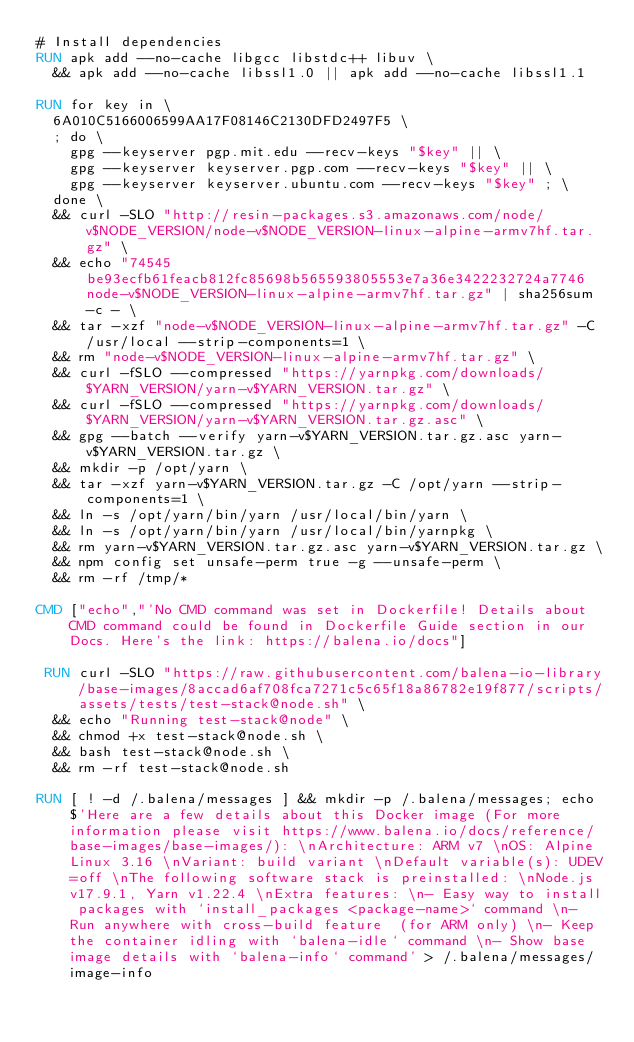<code> <loc_0><loc_0><loc_500><loc_500><_Dockerfile_># Install dependencies
RUN apk add --no-cache libgcc libstdc++ libuv \
	&& apk add --no-cache libssl1.0 || apk add --no-cache libssl1.1

RUN for key in \
	6A010C5166006599AA17F08146C2130DFD2497F5 \
	; do \
		gpg --keyserver pgp.mit.edu --recv-keys "$key" || \
		gpg --keyserver keyserver.pgp.com --recv-keys "$key" || \
		gpg --keyserver keyserver.ubuntu.com --recv-keys "$key" ; \
	done \
	&& curl -SLO "http://resin-packages.s3.amazonaws.com/node/v$NODE_VERSION/node-v$NODE_VERSION-linux-alpine-armv7hf.tar.gz" \
	&& echo "74545be93ecfb61feacb812fc85698b565593805553e7a36e3422232724a7746  node-v$NODE_VERSION-linux-alpine-armv7hf.tar.gz" | sha256sum -c - \
	&& tar -xzf "node-v$NODE_VERSION-linux-alpine-armv7hf.tar.gz" -C /usr/local --strip-components=1 \
	&& rm "node-v$NODE_VERSION-linux-alpine-armv7hf.tar.gz" \
	&& curl -fSLO --compressed "https://yarnpkg.com/downloads/$YARN_VERSION/yarn-v$YARN_VERSION.tar.gz" \
	&& curl -fSLO --compressed "https://yarnpkg.com/downloads/$YARN_VERSION/yarn-v$YARN_VERSION.tar.gz.asc" \
	&& gpg --batch --verify yarn-v$YARN_VERSION.tar.gz.asc yarn-v$YARN_VERSION.tar.gz \
	&& mkdir -p /opt/yarn \
	&& tar -xzf yarn-v$YARN_VERSION.tar.gz -C /opt/yarn --strip-components=1 \
	&& ln -s /opt/yarn/bin/yarn /usr/local/bin/yarn \
	&& ln -s /opt/yarn/bin/yarn /usr/local/bin/yarnpkg \
	&& rm yarn-v$YARN_VERSION.tar.gz.asc yarn-v$YARN_VERSION.tar.gz \
	&& npm config set unsafe-perm true -g --unsafe-perm \
	&& rm -rf /tmp/*

CMD ["echo","'No CMD command was set in Dockerfile! Details about CMD command could be found in Dockerfile Guide section in our Docs. Here's the link: https://balena.io/docs"]

 RUN curl -SLO "https://raw.githubusercontent.com/balena-io-library/base-images/8accad6af708fca7271c5c65f18a86782e19f877/scripts/assets/tests/test-stack@node.sh" \
  && echo "Running test-stack@node" \
  && chmod +x test-stack@node.sh \
  && bash test-stack@node.sh \
  && rm -rf test-stack@node.sh 

RUN [ ! -d /.balena/messages ] && mkdir -p /.balena/messages; echo $'Here are a few details about this Docker image (For more information please visit https://www.balena.io/docs/reference/base-images/base-images/): \nArchitecture: ARM v7 \nOS: Alpine Linux 3.16 \nVariant: build variant \nDefault variable(s): UDEV=off \nThe following software stack is preinstalled: \nNode.js v17.9.1, Yarn v1.22.4 \nExtra features: \n- Easy way to install packages with `install_packages <package-name>` command \n- Run anywhere with cross-build feature  (for ARM only) \n- Keep the container idling with `balena-idle` command \n- Show base image details with `balena-info` command' > /.balena/messages/image-info</code> 